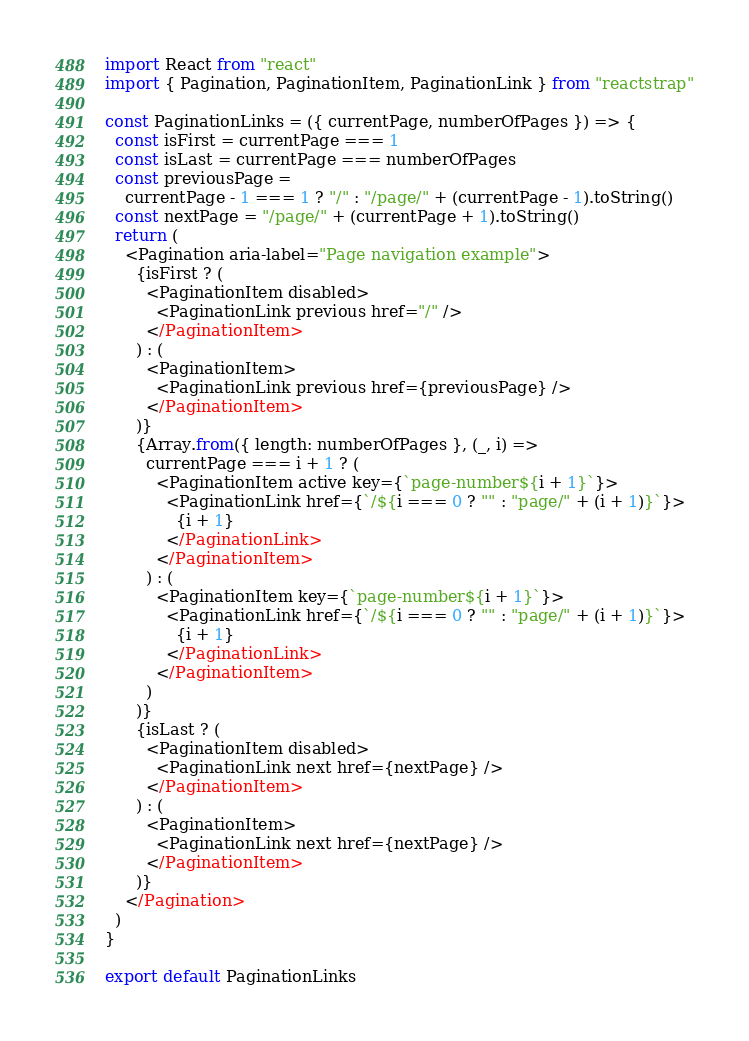<code> <loc_0><loc_0><loc_500><loc_500><_JavaScript_>import React from "react"
import { Pagination, PaginationItem, PaginationLink } from "reactstrap"

const PaginationLinks = ({ currentPage, numberOfPages }) => {
  const isFirst = currentPage === 1
  const isLast = currentPage === numberOfPages
  const previousPage =
    currentPage - 1 === 1 ? "/" : "/page/" + (currentPage - 1).toString()
  const nextPage = "/page/" + (currentPage + 1).toString()
  return (
    <Pagination aria-label="Page navigation example">
      {isFirst ? (
        <PaginationItem disabled>
          <PaginationLink previous href="/" />
        </PaginationItem>
      ) : (
        <PaginationItem>
          <PaginationLink previous href={previousPage} />
        </PaginationItem>
      )}
      {Array.from({ length: numberOfPages }, (_, i) =>
        currentPage === i + 1 ? (
          <PaginationItem active key={`page-number${i + 1}`}>
            <PaginationLink href={`/${i === 0 ? "" : "page/" + (i + 1)}`}>
              {i + 1}
            </PaginationLink>
          </PaginationItem>
        ) : (
          <PaginationItem key={`page-number${i + 1}`}>
            <PaginationLink href={`/${i === 0 ? "" : "page/" + (i + 1)}`}>
              {i + 1}
            </PaginationLink>
          </PaginationItem>
        )
      )}
      {isLast ? (
        <PaginationItem disabled>
          <PaginationLink next href={nextPage} />
        </PaginationItem>
      ) : (
        <PaginationItem>
          <PaginationLink next href={nextPage} />
        </PaginationItem>
      )}
    </Pagination>
  )
}

export default PaginationLinks
</code> 